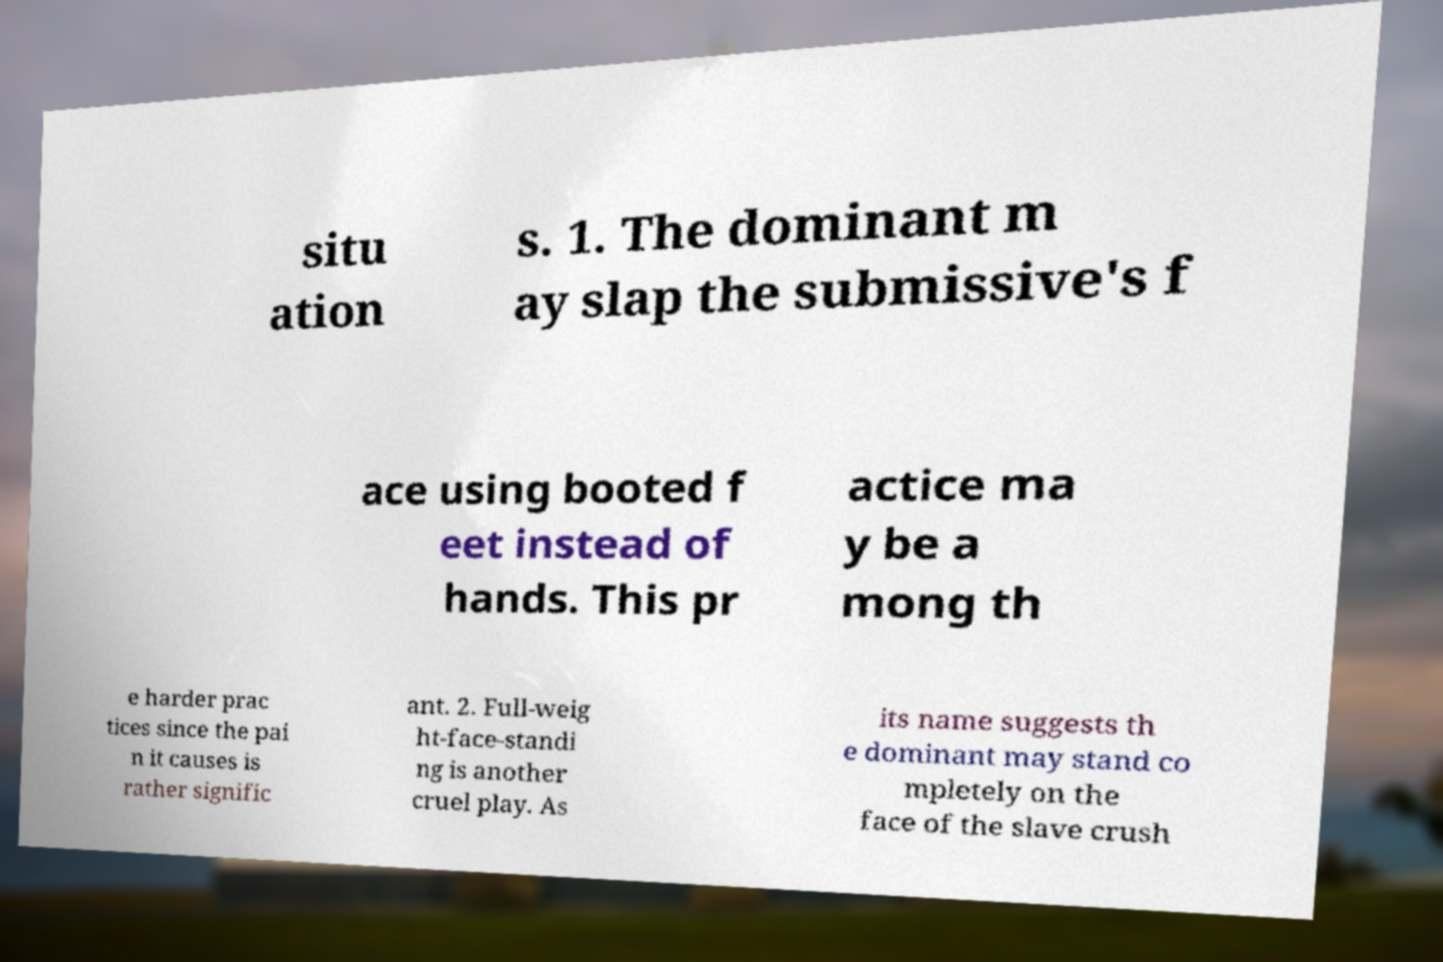For documentation purposes, I need the text within this image transcribed. Could you provide that? situ ation s. 1. The dominant m ay slap the submissive's f ace using booted f eet instead of hands. This pr actice ma y be a mong th e harder prac tices since the pai n it causes is rather signific ant. 2. Full-weig ht-face-standi ng is another cruel play. As its name suggests th e dominant may stand co mpletely on the face of the slave crush 